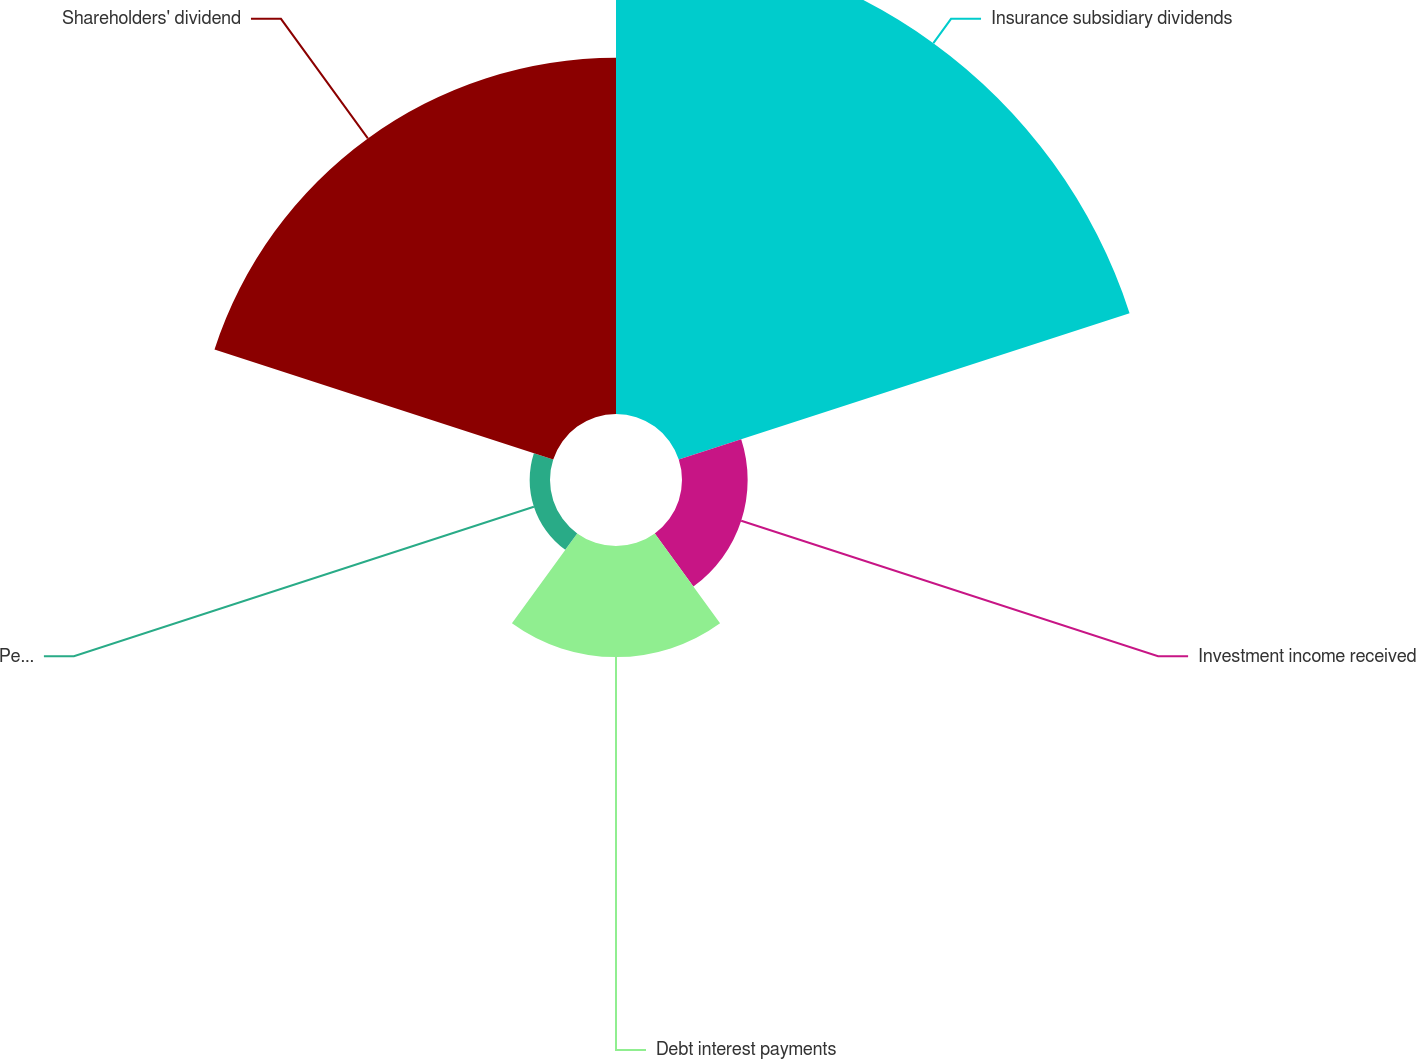Convert chart to OTSL. <chart><loc_0><loc_0><loc_500><loc_500><pie_chart><fcel>Insurance subsidiary dividends<fcel>Investment income received<fcel>Debt interest payments<fcel>Pension contribution<fcel>Shareholders' dividend<nl><fcel>46.14%<fcel>6.39%<fcel>10.81%<fcel>1.98%<fcel>34.67%<nl></chart> 